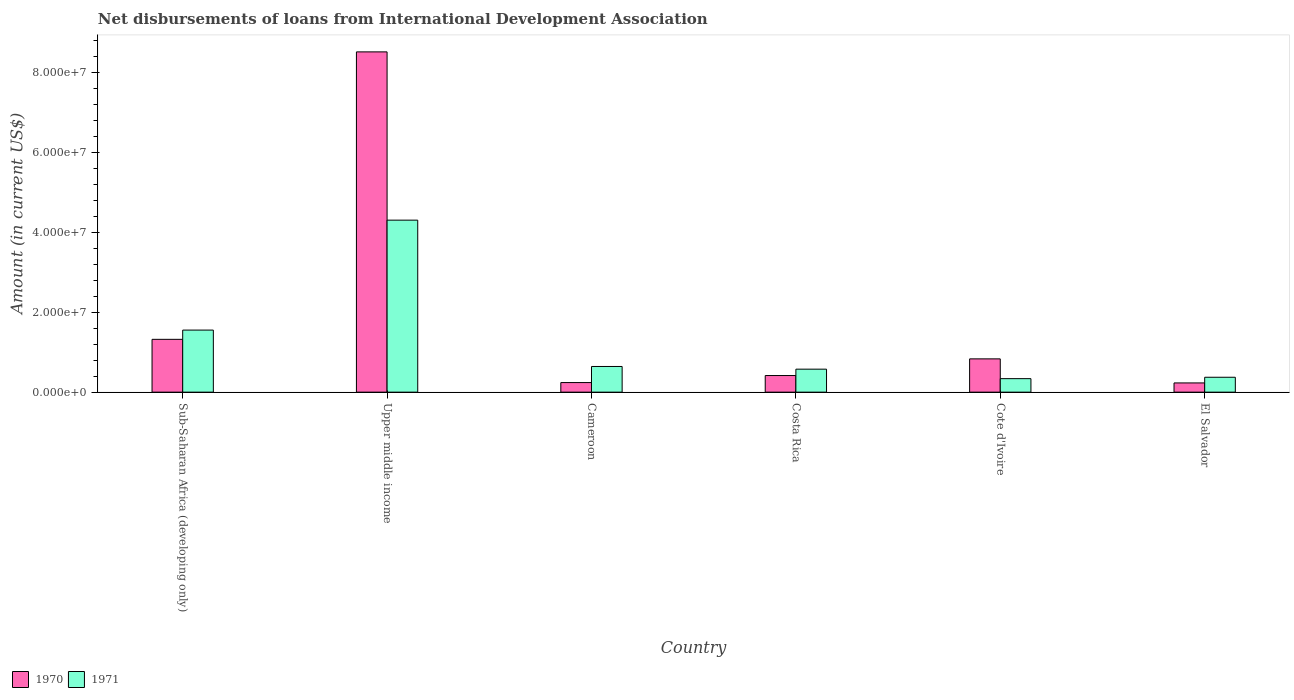How many groups of bars are there?
Your answer should be compact. 6. How many bars are there on the 4th tick from the left?
Offer a terse response. 2. What is the label of the 4th group of bars from the left?
Your answer should be very brief. Costa Rica. What is the amount of loans disbursed in 1970 in El Salvador?
Your response must be concise. 2.30e+06. Across all countries, what is the maximum amount of loans disbursed in 1971?
Offer a terse response. 4.30e+07. Across all countries, what is the minimum amount of loans disbursed in 1971?
Give a very brief answer. 3.37e+06. In which country was the amount of loans disbursed in 1971 maximum?
Offer a terse response. Upper middle income. In which country was the amount of loans disbursed in 1970 minimum?
Your answer should be very brief. El Salvador. What is the total amount of loans disbursed in 1971 in the graph?
Give a very brief answer. 7.78e+07. What is the difference between the amount of loans disbursed in 1970 in El Salvador and that in Sub-Saharan Africa (developing only)?
Make the answer very short. -1.09e+07. What is the difference between the amount of loans disbursed in 1971 in Cameroon and the amount of loans disbursed in 1970 in Sub-Saharan Africa (developing only)?
Your answer should be very brief. -6.78e+06. What is the average amount of loans disbursed in 1970 per country?
Your answer should be compact. 1.92e+07. What is the difference between the amount of loans disbursed of/in 1971 and amount of loans disbursed of/in 1970 in Cameroon?
Your response must be concise. 4.02e+06. In how many countries, is the amount of loans disbursed in 1971 greater than 4000000 US$?
Provide a succinct answer. 4. What is the ratio of the amount of loans disbursed in 1971 in Cameroon to that in Upper middle income?
Offer a very short reply. 0.15. Is the amount of loans disbursed in 1971 in Cameroon less than that in Costa Rica?
Your answer should be compact. No. What is the difference between the highest and the second highest amount of loans disbursed in 1971?
Your answer should be very brief. 3.66e+07. What is the difference between the highest and the lowest amount of loans disbursed in 1971?
Offer a very short reply. 3.96e+07. Is the sum of the amount of loans disbursed in 1970 in Costa Rica and El Salvador greater than the maximum amount of loans disbursed in 1971 across all countries?
Offer a terse response. No. What does the 1st bar from the left in Upper middle income represents?
Offer a very short reply. 1970. How many bars are there?
Your answer should be very brief. 12. Are all the bars in the graph horizontal?
Your answer should be compact. No. How many countries are there in the graph?
Your answer should be very brief. 6. What is the difference between two consecutive major ticks on the Y-axis?
Provide a succinct answer. 2.00e+07. Does the graph contain grids?
Offer a terse response. No. How many legend labels are there?
Give a very brief answer. 2. How are the legend labels stacked?
Keep it short and to the point. Horizontal. What is the title of the graph?
Provide a short and direct response. Net disbursements of loans from International Development Association. What is the label or title of the X-axis?
Offer a very short reply. Country. What is the Amount (in current US$) of 1970 in Sub-Saharan Africa (developing only)?
Provide a succinct answer. 1.32e+07. What is the Amount (in current US$) of 1971 in Sub-Saharan Africa (developing only)?
Your answer should be compact. 1.55e+07. What is the Amount (in current US$) of 1970 in Upper middle income?
Your answer should be very brief. 8.51e+07. What is the Amount (in current US$) in 1971 in Upper middle income?
Provide a succinct answer. 4.30e+07. What is the Amount (in current US$) in 1970 in Cameroon?
Your answer should be compact. 2.40e+06. What is the Amount (in current US$) of 1971 in Cameroon?
Make the answer very short. 6.42e+06. What is the Amount (in current US$) in 1970 in Costa Rica?
Your answer should be compact. 4.15e+06. What is the Amount (in current US$) in 1971 in Costa Rica?
Your answer should be compact. 5.74e+06. What is the Amount (in current US$) in 1970 in Cote d'Ivoire?
Offer a very short reply. 8.32e+06. What is the Amount (in current US$) in 1971 in Cote d'Ivoire?
Make the answer very short. 3.37e+06. What is the Amount (in current US$) in 1970 in El Salvador?
Give a very brief answer. 2.30e+06. What is the Amount (in current US$) of 1971 in El Salvador?
Offer a very short reply. 3.72e+06. Across all countries, what is the maximum Amount (in current US$) of 1970?
Offer a very short reply. 8.51e+07. Across all countries, what is the maximum Amount (in current US$) in 1971?
Your answer should be very brief. 4.30e+07. Across all countries, what is the minimum Amount (in current US$) of 1970?
Give a very brief answer. 2.30e+06. Across all countries, what is the minimum Amount (in current US$) of 1971?
Your answer should be very brief. 3.37e+06. What is the total Amount (in current US$) in 1970 in the graph?
Provide a short and direct response. 1.15e+08. What is the total Amount (in current US$) in 1971 in the graph?
Make the answer very short. 7.78e+07. What is the difference between the Amount (in current US$) of 1970 in Sub-Saharan Africa (developing only) and that in Upper middle income?
Offer a very short reply. -7.19e+07. What is the difference between the Amount (in current US$) in 1971 in Sub-Saharan Africa (developing only) and that in Upper middle income?
Ensure brevity in your answer.  -2.75e+07. What is the difference between the Amount (in current US$) in 1970 in Sub-Saharan Africa (developing only) and that in Cameroon?
Keep it short and to the point. 1.08e+07. What is the difference between the Amount (in current US$) in 1971 in Sub-Saharan Africa (developing only) and that in Cameroon?
Your answer should be very brief. 9.10e+06. What is the difference between the Amount (in current US$) in 1970 in Sub-Saharan Africa (developing only) and that in Costa Rica?
Your response must be concise. 9.05e+06. What is the difference between the Amount (in current US$) in 1971 in Sub-Saharan Africa (developing only) and that in Costa Rica?
Ensure brevity in your answer.  9.77e+06. What is the difference between the Amount (in current US$) in 1970 in Sub-Saharan Africa (developing only) and that in Cote d'Ivoire?
Your response must be concise. 4.88e+06. What is the difference between the Amount (in current US$) in 1971 in Sub-Saharan Africa (developing only) and that in Cote d'Ivoire?
Your answer should be compact. 1.21e+07. What is the difference between the Amount (in current US$) of 1970 in Sub-Saharan Africa (developing only) and that in El Salvador?
Make the answer very short. 1.09e+07. What is the difference between the Amount (in current US$) of 1971 in Sub-Saharan Africa (developing only) and that in El Salvador?
Ensure brevity in your answer.  1.18e+07. What is the difference between the Amount (in current US$) of 1970 in Upper middle income and that in Cameroon?
Your response must be concise. 8.27e+07. What is the difference between the Amount (in current US$) of 1971 in Upper middle income and that in Cameroon?
Ensure brevity in your answer.  3.66e+07. What is the difference between the Amount (in current US$) of 1970 in Upper middle income and that in Costa Rica?
Offer a very short reply. 8.09e+07. What is the difference between the Amount (in current US$) of 1971 in Upper middle income and that in Costa Rica?
Provide a short and direct response. 3.73e+07. What is the difference between the Amount (in current US$) of 1970 in Upper middle income and that in Cote d'Ivoire?
Provide a short and direct response. 7.67e+07. What is the difference between the Amount (in current US$) of 1971 in Upper middle income and that in Cote d'Ivoire?
Your answer should be compact. 3.96e+07. What is the difference between the Amount (in current US$) of 1970 in Upper middle income and that in El Salvador?
Give a very brief answer. 8.28e+07. What is the difference between the Amount (in current US$) in 1971 in Upper middle income and that in El Salvador?
Your answer should be very brief. 3.93e+07. What is the difference between the Amount (in current US$) of 1970 in Cameroon and that in Costa Rica?
Provide a succinct answer. -1.76e+06. What is the difference between the Amount (in current US$) of 1971 in Cameroon and that in Costa Rica?
Ensure brevity in your answer.  6.75e+05. What is the difference between the Amount (in current US$) of 1970 in Cameroon and that in Cote d'Ivoire?
Offer a terse response. -5.92e+06. What is the difference between the Amount (in current US$) of 1971 in Cameroon and that in Cote d'Ivoire?
Keep it short and to the point. 3.04e+06. What is the difference between the Amount (in current US$) of 1970 in Cameroon and that in El Salvador?
Your answer should be very brief. 9.30e+04. What is the difference between the Amount (in current US$) of 1971 in Cameroon and that in El Salvador?
Provide a short and direct response. 2.70e+06. What is the difference between the Amount (in current US$) in 1970 in Costa Rica and that in Cote d'Ivoire?
Keep it short and to the point. -4.17e+06. What is the difference between the Amount (in current US$) of 1971 in Costa Rica and that in Cote d'Ivoire?
Make the answer very short. 2.37e+06. What is the difference between the Amount (in current US$) in 1970 in Costa Rica and that in El Salvador?
Provide a short and direct response. 1.85e+06. What is the difference between the Amount (in current US$) of 1971 in Costa Rica and that in El Salvador?
Offer a terse response. 2.02e+06. What is the difference between the Amount (in current US$) in 1970 in Cote d'Ivoire and that in El Salvador?
Offer a terse response. 6.02e+06. What is the difference between the Amount (in current US$) of 1971 in Cote d'Ivoire and that in El Salvador?
Make the answer very short. -3.50e+05. What is the difference between the Amount (in current US$) in 1970 in Sub-Saharan Africa (developing only) and the Amount (in current US$) in 1971 in Upper middle income?
Ensure brevity in your answer.  -2.98e+07. What is the difference between the Amount (in current US$) in 1970 in Sub-Saharan Africa (developing only) and the Amount (in current US$) in 1971 in Cameroon?
Make the answer very short. 6.78e+06. What is the difference between the Amount (in current US$) in 1970 in Sub-Saharan Africa (developing only) and the Amount (in current US$) in 1971 in Costa Rica?
Provide a short and direct response. 7.46e+06. What is the difference between the Amount (in current US$) in 1970 in Sub-Saharan Africa (developing only) and the Amount (in current US$) in 1971 in Cote d'Ivoire?
Your answer should be very brief. 9.83e+06. What is the difference between the Amount (in current US$) in 1970 in Sub-Saharan Africa (developing only) and the Amount (in current US$) in 1971 in El Salvador?
Give a very brief answer. 9.48e+06. What is the difference between the Amount (in current US$) of 1970 in Upper middle income and the Amount (in current US$) of 1971 in Cameroon?
Offer a very short reply. 7.86e+07. What is the difference between the Amount (in current US$) in 1970 in Upper middle income and the Amount (in current US$) in 1971 in Costa Rica?
Offer a very short reply. 7.93e+07. What is the difference between the Amount (in current US$) of 1970 in Upper middle income and the Amount (in current US$) of 1971 in Cote d'Ivoire?
Provide a short and direct response. 8.17e+07. What is the difference between the Amount (in current US$) in 1970 in Upper middle income and the Amount (in current US$) in 1971 in El Salvador?
Your response must be concise. 8.13e+07. What is the difference between the Amount (in current US$) of 1970 in Cameroon and the Amount (in current US$) of 1971 in Costa Rica?
Keep it short and to the point. -3.35e+06. What is the difference between the Amount (in current US$) of 1970 in Cameroon and the Amount (in current US$) of 1971 in Cote d'Ivoire?
Give a very brief answer. -9.78e+05. What is the difference between the Amount (in current US$) of 1970 in Cameroon and the Amount (in current US$) of 1971 in El Salvador?
Your response must be concise. -1.33e+06. What is the difference between the Amount (in current US$) in 1970 in Costa Rica and the Amount (in current US$) in 1971 in Cote d'Ivoire?
Give a very brief answer. 7.79e+05. What is the difference between the Amount (in current US$) of 1970 in Costa Rica and the Amount (in current US$) of 1971 in El Salvador?
Keep it short and to the point. 4.29e+05. What is the difference between the Amount (in current US$) of 1970 in Cote d'Ivoire and the Amount (in current US$) of 1971 in El Salvador?
Ensure brevity in your answer.  4.60e+06. What is the average Amount (in current US$) in 1970 per country?
Provide a succinct answer. 1.92e+07. What is the average Amount (in current US$) of 1971 per country?
Offer a terse response. 1.30e+07. What is the difference between the Amount (in current US$) of 1970 and Amount (in current US$) of 1971 in Sub-Saharan Africa (developing only)?
Keep it short and to the point. -2.31e+06. What is the difference between the Amount (in current US$) of 1970 and Amount (in current US$) of 1971 in Upper middle income?
Your response must be concise. 4.21e+07. What is the difference between the Amount (in current US$) of 1970 and Amount (in current US$) of 1971 in Cameroon?
Make the answer very short. -4.02e+06. What is the difference between the Amount (in current US$) in 1970 and Amount (in current US$) in 1971 in Costa Rica?
Provide a short and direct response. -1.59e+06. What is the difference between the Amount (in current US$) of 1970 and Amount (in current US$) of 1971 in Cote d'Ivoire?
Your answer should be compact. 4.95e+06. What is the difference between the Amount (in current US$) in 1970 and Amount (in current US$) in 1971 in El Salvador?
Provide a succinct answer. -1.42e+06. What is the ratio of the Amount (in current US$) of 1970 in Sub-Saharan Africa (developing only) to that in Upper middle income?
Offer a terse response. 0.16. What is the ratio of the Amount (in current US$) of 1971 in Sub-Saharan Africa (developing only) to that in Upper middle income?
Your answer should be compact. 0.36. What is the ratio of the Amount (in current US$) in 1970 in Sub-Saharan Africa (developing only) to that in Cameroon?
Keep it short and to the point. 5.51. What is the ratio of the Amount (in current US$) in 1971 in Sub-Saharan Africa (developing only) to that in Cameroon?
Provide a succinct answer. 2.42. What is the ratio of the Amount (in current US$) of 1970 in Sub-Saharan Africa (developing only) to that in Costa Rica?
Provide a short and direct response. 3.18. What is the ratio of the Amount (in current US$) in 1971 in Sub-Saharan Africa (developing only) to that in Costa Rica?
Give a very brief answer. 2.7. What is the ratio of the Amount (in current US$) of 1970 in Sub-Saharan Africa (developing only) to that in Cote d'Ivoire?
Provide a succinct answer. 1.59. What is the ratio of the Amount (in current US$) of 1971 in Sub-Saharan Africa (developing only) to that in Cote d'Ivoire?
Ensure brevity in your answer.  4.6. What is the ratio of the Amount (in current US$) in 1970 in Sub-Saharan Africa (developing only) to that in El Salvador?
Give a very brief answer. 5.73. What is the ratio of the Amount (in current US$) of 1971 in Sub-Saharan Africa (developing only) to that in El Salvador?
Offer a terse response. 4.17. What is the ratio of the Amount (in current US$) in 1970 in Upper middle income to that in Cameroon?
Give a very brief answer. 35.5. What is the ratio of the Amount (in current US$) of 1971 in Upper middle income to that in Cameroon?
Keep it short and to the point. 6.7. What is the ratio of the Amount (in current US$) of 1970 in Upper middle income to that in Costa Rica?
Give a very brief answer. 20.48. What is the ratio of the Amount (in current US$) of 1971 in Upper middle income to that in Costa Rica?
Your response must be concise. 7.49. What is the ratio of the Amount (in current US$) of 1970 in Upper middle income to that in Cote d'Ivoire?
Offer a terse response. 10.22. What is the ratio of the Amount (in current US$) in 1971 in Upper middle income to that in Cote d'Ivoire?
Your response must be concise. 12.74. What is the ratio of the Amount (in current US$) in 1970 in Upper middle income to that in El Salvador?
Make the answer very short. 36.94. What is the ratio of the Amount (in current US$) in 1971 in Upper middle income to that in El Salvador?
Offer a very short reply. 11.55. What is the ratio of the Amount (in current US$) in 1970 in Cameroon to that in Costa Rica?
Keep it short and to the point. 0.58. What is the ratio of the Amount (in current US$) in 1971 in Cameroon to that in Costa Rica?
Provide a short and direct response. 1.12. What is the ratio of the Amount (in current US$) of 1970 in Cameroon to that in Cote d'Ivoire?
Make the answer very short. 0.29. What is the ratio of the Amount (in current US$) in 1971 in Cameroon to that in Cote d'Ivoire?
Make the answer very short. 1.9. What is the ratio of the Amount (in current US$) in 1970 in Cameroon to that in El Salvador?
Make the answer very short. 1.04. What is the ratio of the Amount (in current US$) in 1971 in Cameroon to that in El Salvador?
Your response must be concise. 1.72. What is the ratio of the Amount (in current US$) of 1970 in Costa Rica to that in Cote d'Ivoire?
Offer a very short reply. 0.5. What is the ratio of the Amount (in current US$) of 1971 in Costa Rica to that in Cote d'Ivoire?
Ensure brevity in your answer.  1.7. What is the ratio of the Amount (in current US$) of 1970 in Costa Rica to that in El Salvador?
Offer a terse response. 1.8. What is the ratio of the Amount (in current US$) in 1971 in Costa Rica to that in El Salvador?
Keep it short and to the point. 1.54. What is the ratio of the Amount (in current US$) in 1970 in Cote d'Ivoire to that in El Salvador?
Give a very brief answer. 3.61. What is the ratio of the Amount (in current US$) in 1971 in Cote d'Ivoire to that in El Salvador?
Make the answer very short. 0.91. What is the difference between the highest and the second highest Amount (in current US$) of 1970?
Keep it short and to the point. 7.19e+07. What is the difference between the highest and the second highest Amount (in current US$) in 1971?
Offer a very short reply. 2.75e+07. What is the difference between the highest and the lowest Amount (in current US$) of 1970?
Ensure brevity in your answer.  8.28e+07. What is the difference between the highest and the lowest Amount (in current US$) in 1971?
Offer a very short reply. 3.96e+07. 